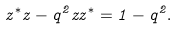<formula> <loc_0><loc_0><loc_500><loc_500>z ^ { \ast } z - q ^ { 2 } z z ^ { \ast } = 1 - q ^ { 2 } .</formula> 